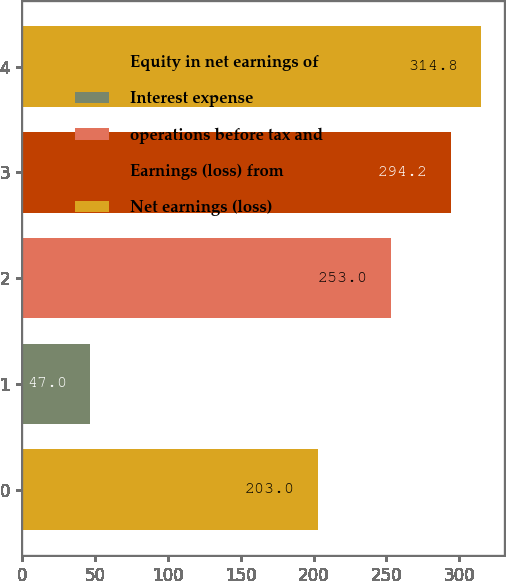Convert chart to OTSL. <chart><loc_0><loc_0><loc_500><loc_500><bar_chart><fcel>Equity in net earnings of<fcel>Interest expense<fcel>operations before tax and<fcel>Earnings (loss) from<fcel>Net earnings (loss)<nl><fcel>203<fcel>47<fcel>253<fcel>294.2<fcel>314.8<nl></chart> 